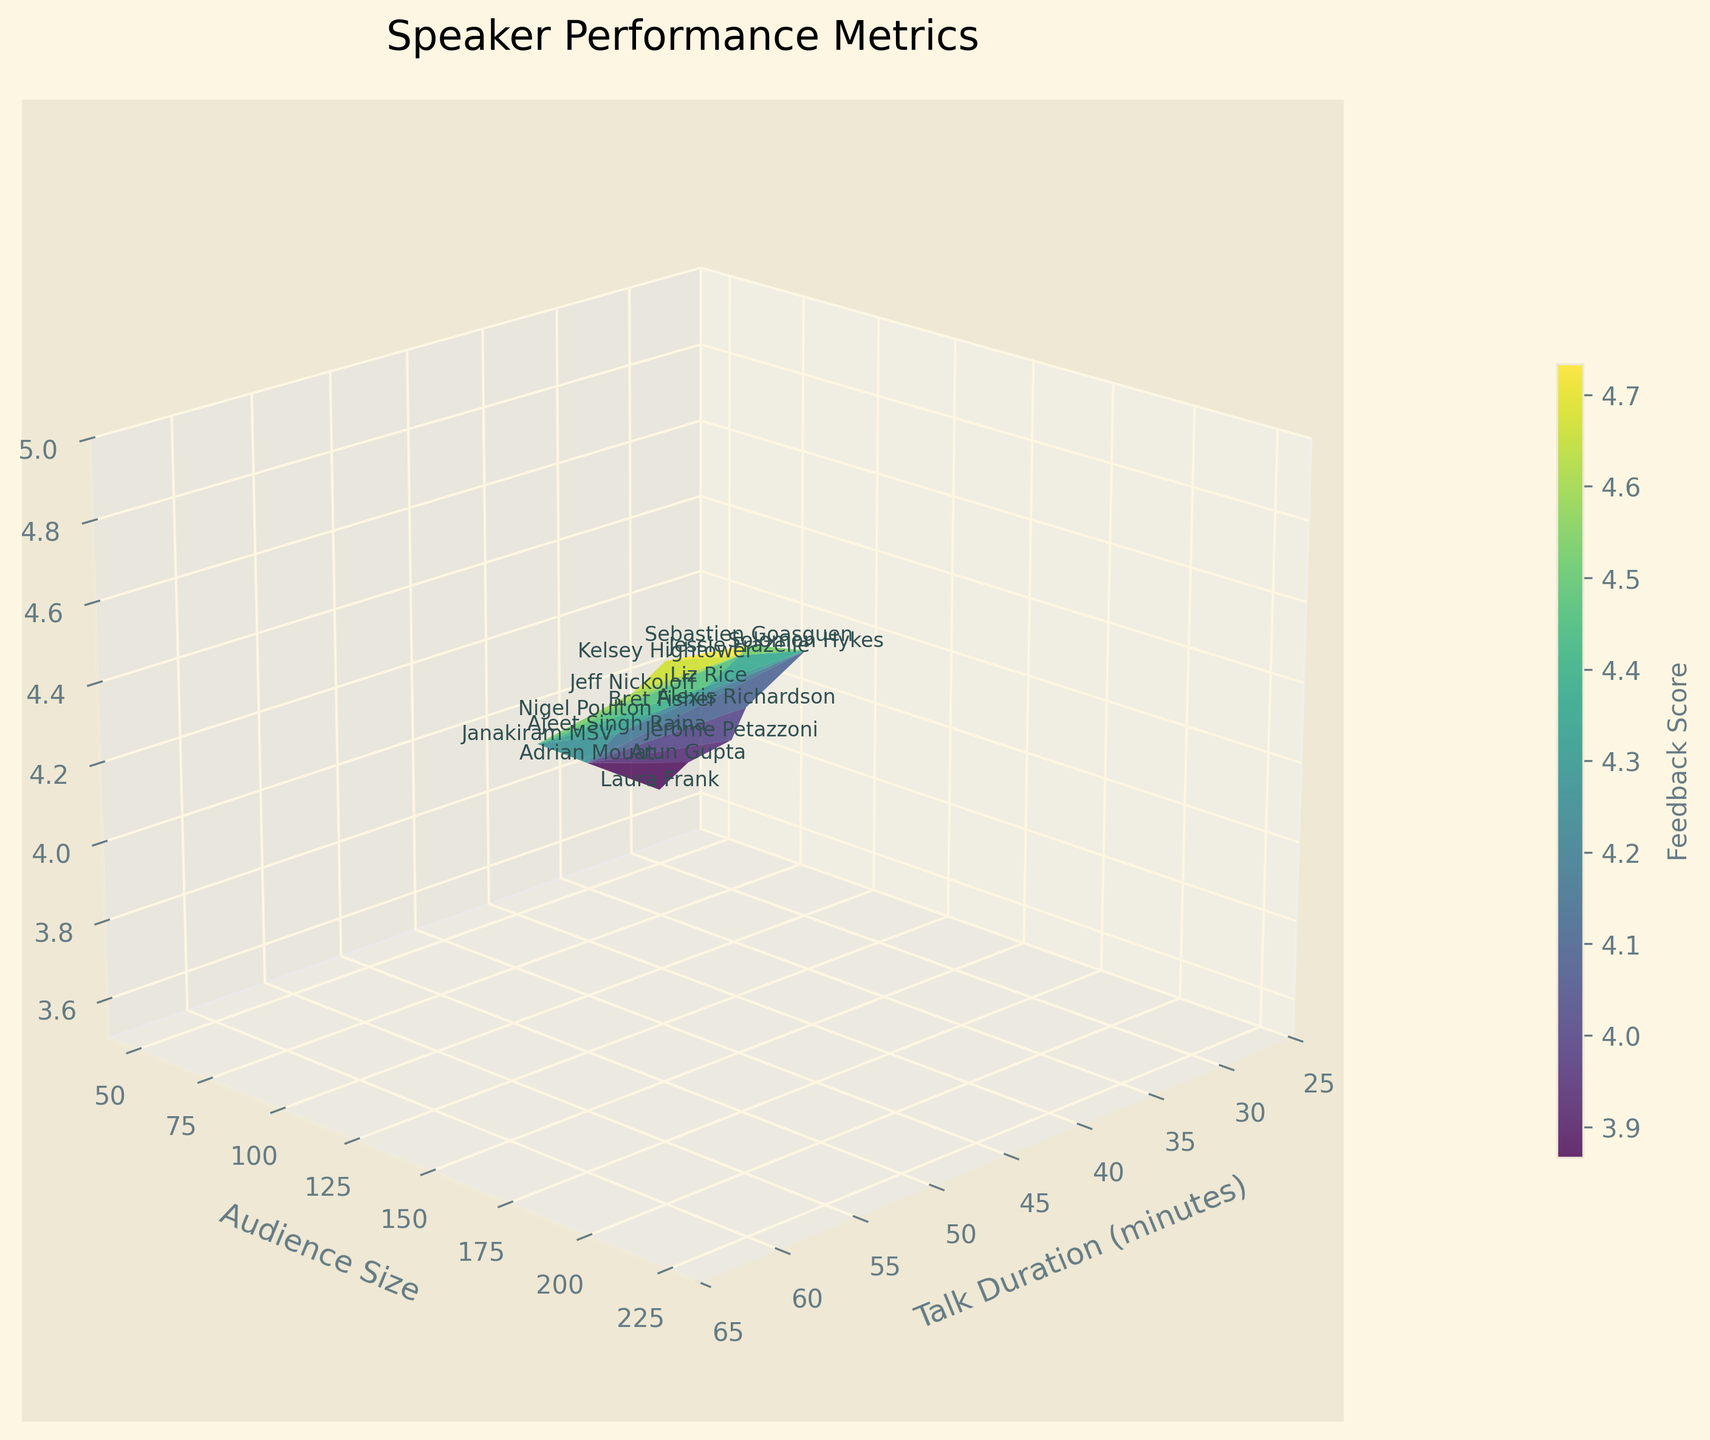What is the title of the figure? Look at the top of the figure; the title is typically present in a bold or prominent font.
Answer: Speaker Performance Metrics What are the ranges for the X, Y, and Z axes? For the Talk Duration (minutes) axis, look at the values on the axis, which range from 25 to 65 minutes. For the Audience Size axis, the range is 40 to 235. For the Feedback Score axis, it ranges from 3.5 to 5.0.
Answer: X: 25-65, Y: 40-235, Z: 3.5-5.0 Which speaker has the highest Feedback Score? Check the points with the highest z-values (Feedback Scores). Sebastien Goasguen scores the highest.
Answer: Sebastien Goasguen How does the Feedback Score generally trend with increasing Talk Duration? Observe the pattern of points from lower Talk Duration to higher. Feedback Scores generally increase as Talk Duration increases.
Answer: Increases What is the average Feedback Score for the speakers with a 60-minute talk duration? Identify the Feedback Scores for speakers with 60-minute talk durations: 4.8 (Kelsey Hightower), 4.6 (Nigel Poulton), 4.9 (Sebastien Goasguen), 4.7 (Jeff Nickoloff), 4.5 (Janakiram MSV). Sum these scores: 4.8 + 4.6 + 4.9 + 4.7 + 4.5 = 23.5. Divide by 5 to get the average: 23.5 / 5 = 4.7.
Answer: 4.7 Which speaker had the smallest audience size, and what was their Feedback Score? Look for the point with the smallest y-value. Laura Frank had the smallest audience size (50) and her Feedback Score was 3.7.
Answer: Laura Frank, 3.7 How many speakers have a Feedback Score of 4.5 or above? Identify the Feedback Scores above 4.5: Jessie Frazelle, Kelsey Hightower, Sebastien Goasguen, Liz Rice, Jeff Nickoloff, Janakiram MSV. Count the number of these speakers.
Answer: 6 Comparing Bret Fisher and Alexis Richardson, who had a larger audience size? Locate both points on the plot. Bret Fisher (125) and Alexis Richardson (80). Bret Fisher had a larger audience size.
Answer: Bret Fisher Between the 30-minute and 45-minute talk durations, which duration had a generally higher Feedback Score? Compare points at 30 minutes and 45 minutes by examining their z-values. The 45-minute talk duration generally shows a higher Feedback Score.
Answer: 45-minute Does the color gradient in the 3D surface plot convey any specific information? Yes, the color gradient in the surface plot, which ranges in 'viridis' colors, represents the Feedback Scores. Darker colors represent higher scores, and lighter colors represent lower scores.
Answer: Represents Feedback Score 